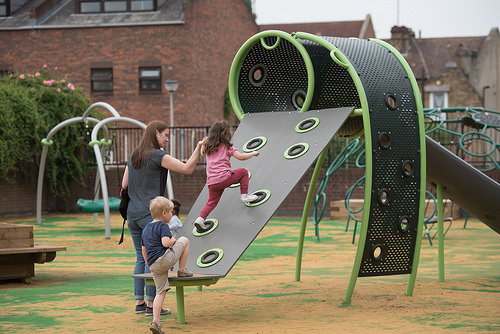<image>
Is there a woman to the left of the girl? Yes. From this viewpoint, the woman is positioned to the left side relative to the girl. Where is the lamppost in relation to the fence? Is it behind the fence? Yes. From this viewpoint, the lamppost is positioned behind the fence, with the fence partially or fully occluding the lamppost. Where is the girl in relation to the boy? Is it in front of the boy? No. The girl is not in front of the boy. The spatial positioning shows a different relationship between these objects. Is there a girl above the boy? Yes. The girl is positioned above the boy in the vertical space, higher up in the scene. 